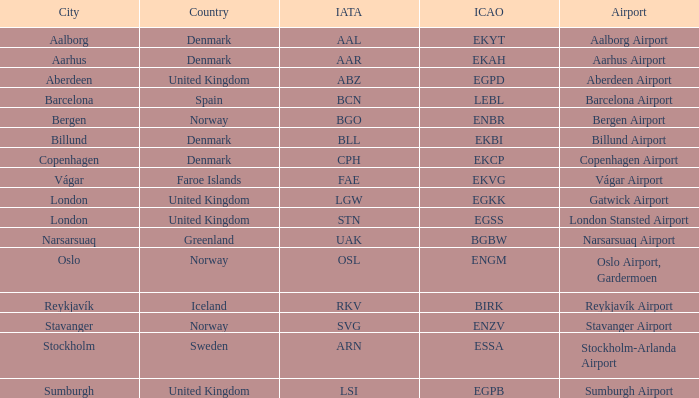What airport has an IATA of ARN? Stockholm-Arlanda Airport. 